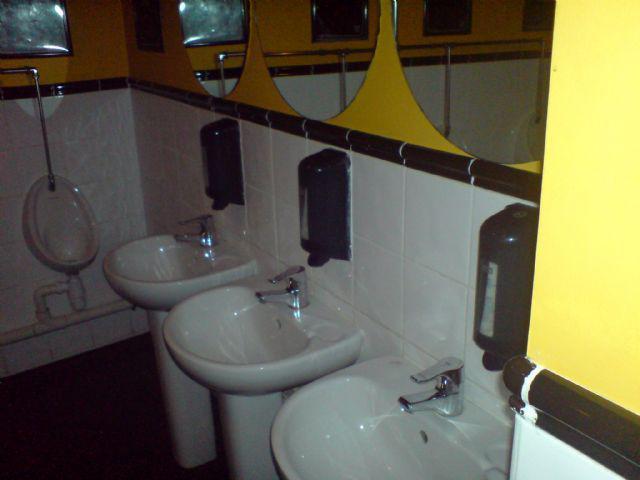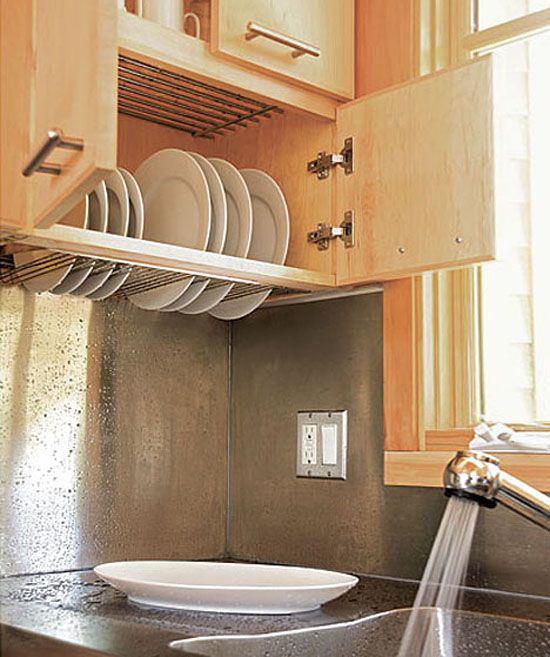The first image is the image on the left, the second image is the image on the right. Assess this claim about the two images: "One of the images displays more than one sink.". Correct or not? Answer yes or no. Yes. The first image is the image on the left, the second image is the image on the right. For the images displayed, is the sentence "A mirror is on a yellow wall above a white sink in one bathroom." factually correct? Answer yes or no. Yes. 